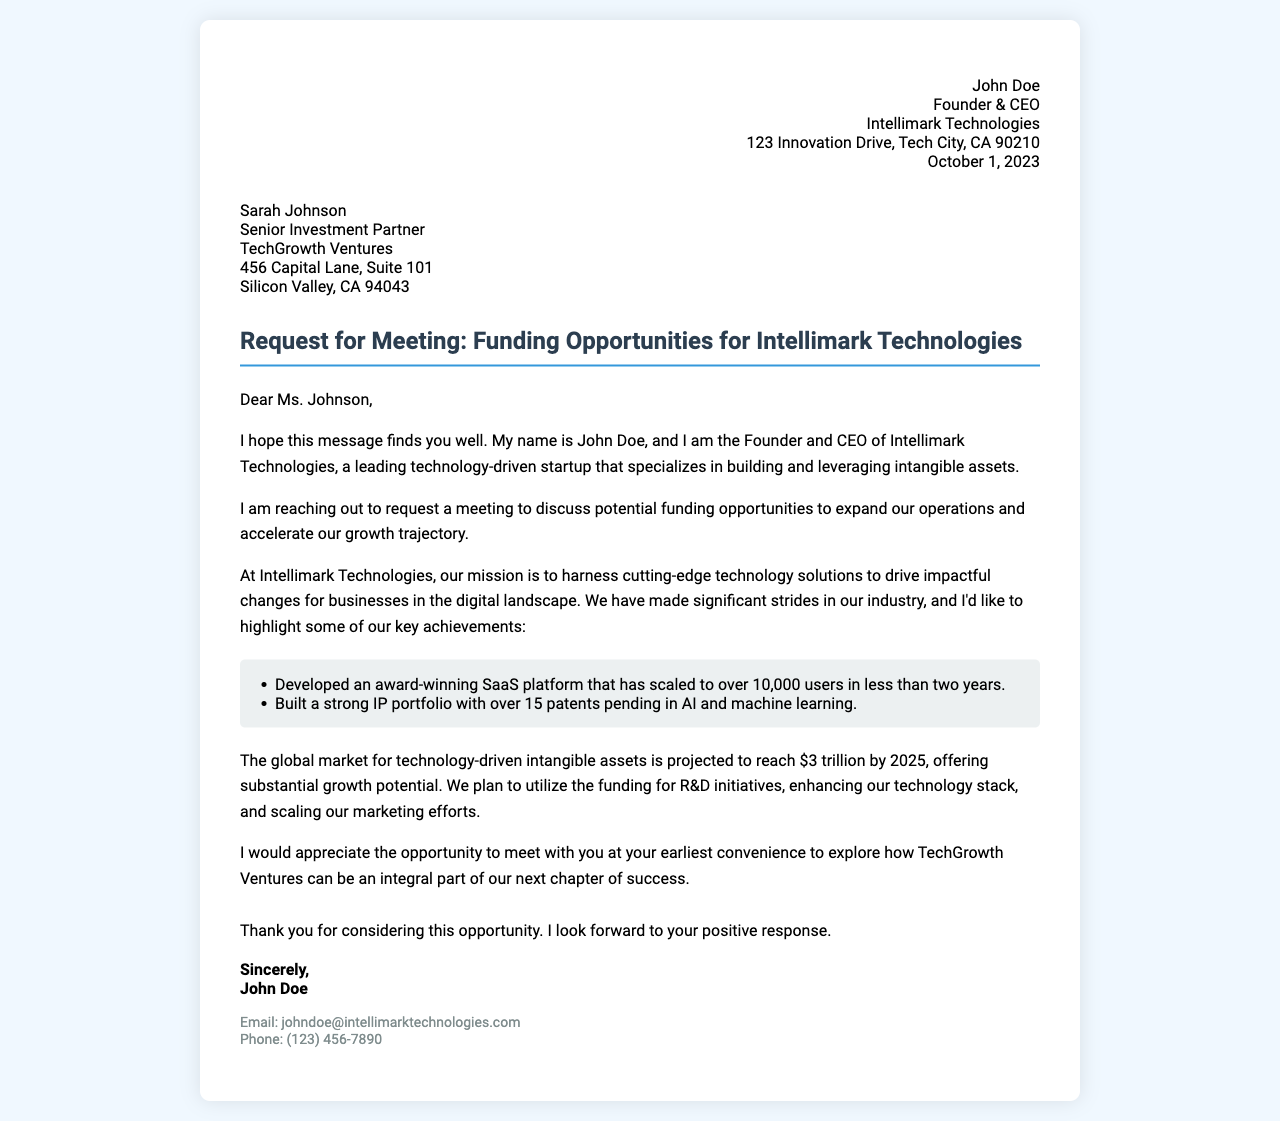What is the name of the company? The name of the company is mentioned in the letter as Intellimark Technologies.
Answer: Intellimark Technologies Who is the recipient of the letter? The recipient of the letter is mentioned in the document as Sarah Johnson.
Answer: Sarah Johnson What is the purpose of the meeting request? The purpose is to discuss potential funding opportunities for expanding operations.
Answer: Funding opportunities When was the letter written? The date on the letter indicates it was written on October 1, 2023.
Answer: October 1, 2023 How many patents are pending? The document specifies that there are over 15 patents pending in AI and machine learning.
Answer: Over 15 What key achievement indicates user growth? The letter highlights the achievement of scaling a SaaS platform to over 10,000 users.
Answer: Over 10,000 users What is the projected market value for technology-driven intangible assets by 2025? The document mentions that the global market is projected to reach $3 trillion by 2025.
Answer: $3 trillion Who is the sender of the letter? The sender is John Doe, as stated at the end of the letter.
Answer: John Doe What is the primary goal for the funding? The primary goal for the funding is to enhance technology stack and scale marketing efforts.
Answer: Enhance technology stack and scale marketing efforts 